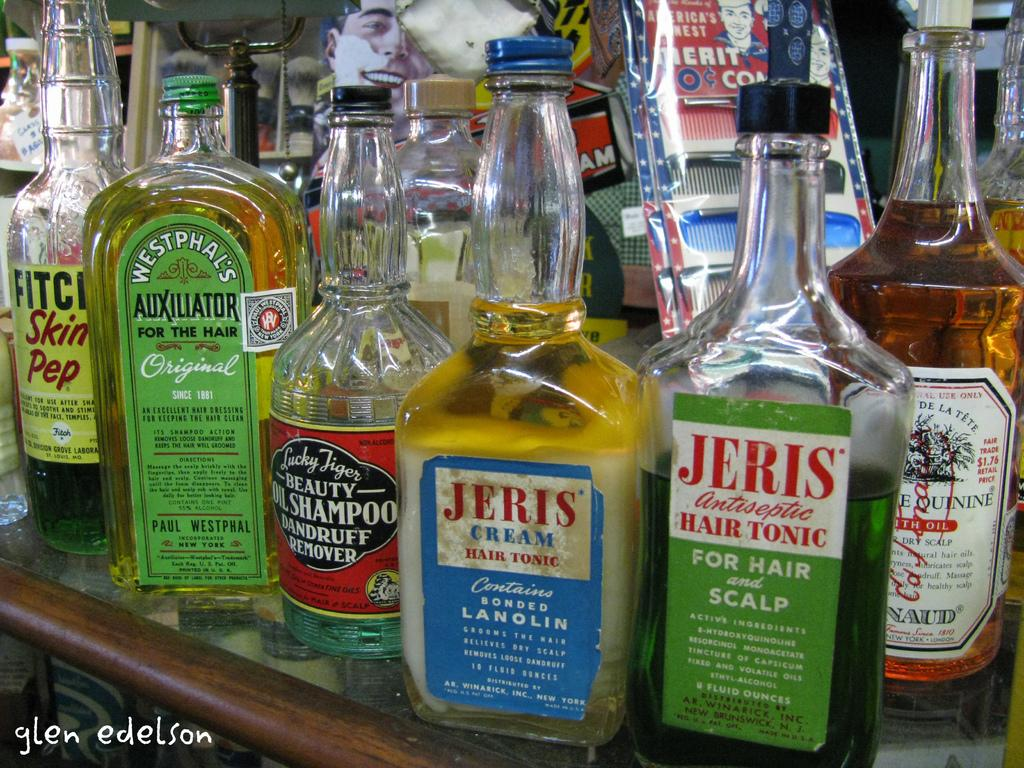Provide a one-sentence caption for the provided image. Several old hair-care bottles are crowded together, including cream hair tonic and oil shampoo for dandruff. 